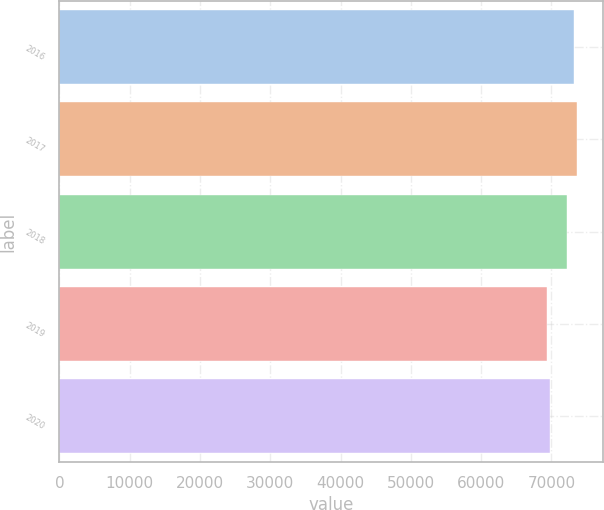Convert chart to OTSL. <chart><loc_0><loc_0><loc_500><loc_500><bar_chart><fcel>2016<fcel>2017<fcel>2018<fcel>2019<fcel>2020<nl><fcel>73208<fcel>73585.5<fcel>72149<fcel>69433<fcel>69810.5<nl></chart> 